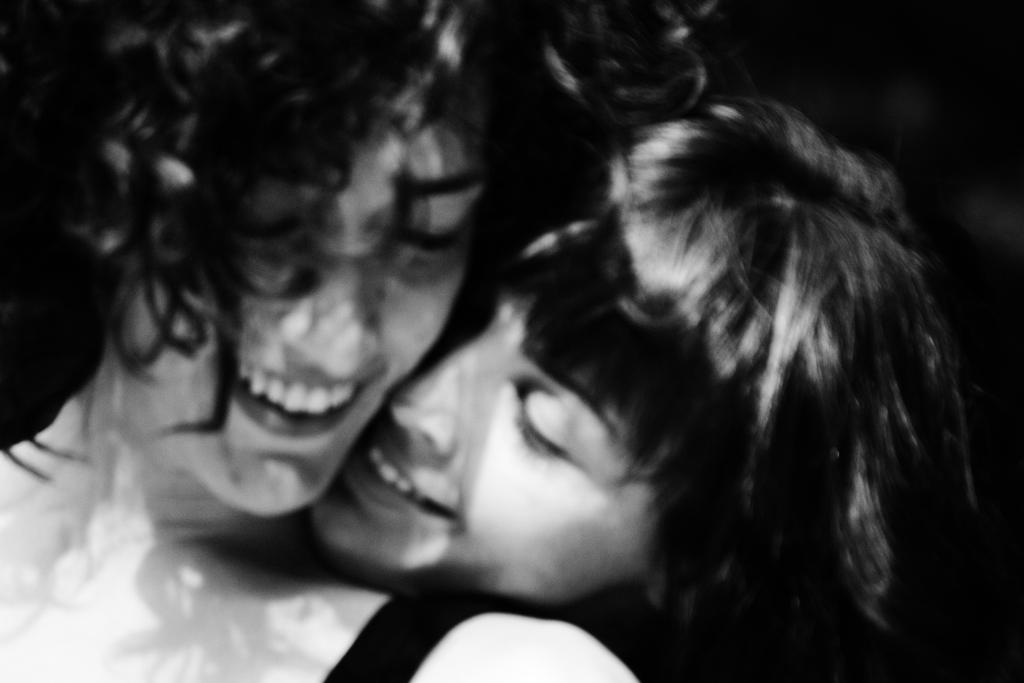How many individuals are present in the image? There are two people in the image. What can be observed about the background of the image? The background of the image is dark. What type of card can be seen being sold in the store in the image? There is no store or card present in the image; it only features two people with a dark background. 